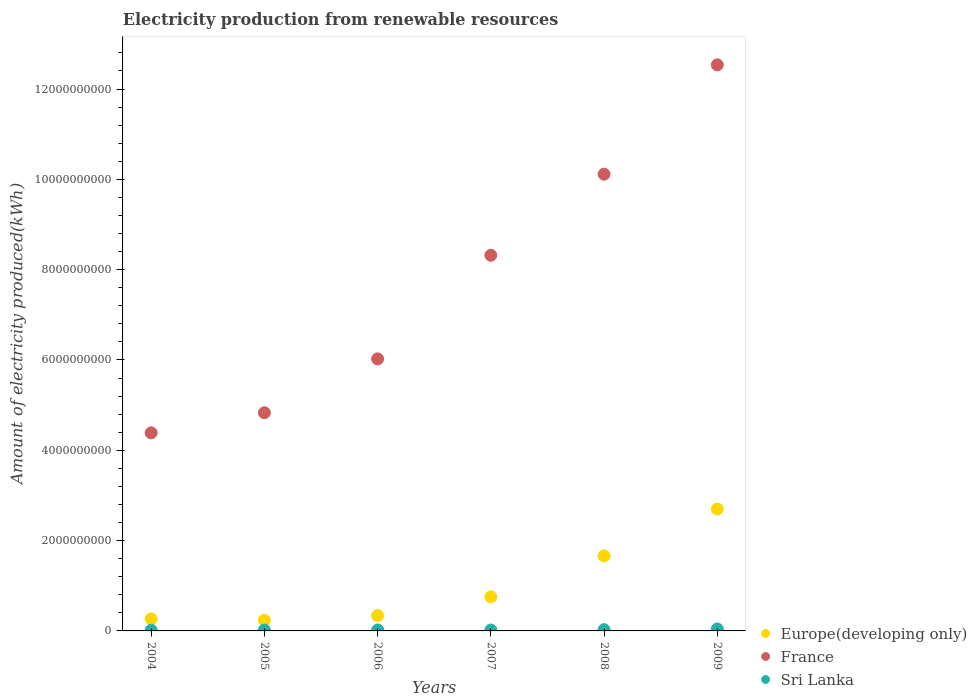How many different coloured dotlines are there?
Provide a short and direct response. 3. Is the number of dotlines equal to the number of legend labels?
Keep it short and to the point. Yes. Across all years, what is the maximum amount of electricity produced in France?
Provide a short and direct response. 1.25e+1. Across all years, what is the minimum amount of electricity produced in Europe(developing only)?
Keep it short and to the point. 2.37e+08. What is the total amount of electricity produced in Sri Lanka in the graph?
Your answer should be very brief. 1.46e+08. What is the difference between the amount of electricity produced in Europe(developing only) in 2007 and that in 2008?
Your answer should be compact. -9.09e+08. What is the difference between the amount of electricity produced in Europe(developing only) in 2004 and the amount of electricity produced in France in 2005?
Offer a very short reply. -4.56e+09. What is the average amount of electricity produced in Sri Lanka per year?
Ensure brevity in your answer.  2.43e+07. In the year 2007, what is the difference between the amount of electricity produced in France and amount of electricity produced in Europe(developing only)?
Offer a terse response. 7.56e+09. In how many years, is the amount of electricity produced in Sri Lanka greater than 2800000000 kWh?
Offer a very short reply. 0. What is the ratio of the amount of electricity produced in France in 2006 to that in 2008?
Ensure brevity in your answer.  0.6. Is the difference between the amount of electricity produced in France in 2008 and 2009 greater than the difference between the amount of electricity produced in Europe(developing only) in 2008 and 2009?
Give a very brief answer. No. What is the difference between the highest and the second highest amount of electricity produced in Sri Lanka?
Offer a very short reply. 1.60e+07. What is the difference between the highest and the lowest amount of electricity produced in Sri Lanka?
Give a very brief answer. 2.80e+07. Is the sum of the amount of electricity produced in Europe(developing only) in 2004 and 2006 greater than the maximum amount of electricity produced in France across all years?
Ensure brevity in your answer.  No. Does the amount of electricity produced in France monotonically increase over the years?
Your answer should be very brief. Yes. Is the amount of electricity produced in Sri Lanka strictly greater than the amount of electricity produced in France over the years?
Provide a short and direct response. No. How many years are there in the graph?
Offer a very short reply. 6. What is the difference between two consecutive major ticks on the Y-axis?
Give a very brief answer. 2.00e+09. Where does the legend appear in the graph?
Your answer should be very brief. Bottom right. How many legend labels are there?
Offer a terse response. 3. What is the title of the graph?
Provide a short and direct response. Electricity production from renewable resources. Does "Virgin Islands" appear as one of the legend labels in the graph?
Keep it short and to the point. No. What is the label or title of the X-axis?
Provide a short and direct response. Years. What is the label or title of the Y-axis?
Provide a short and direct response. Amount of electricity produced(kWh). What is the Amount of electricity produced(kWh) in Europe(developing only) in 2004?
Give a very brief answer. 2.66e+08. What is the Amount of electricity produced(kWh) of France in 2004?
Give a very brief answer. 4.39e+09. What is the Amount of electricity produced(kWh) of Sri Lanka in 2004?
Give a very brief answer. 1.50e+07. What is the Amount of electricity produced(kWh) in Europe(developing only) in 2005?
Your answer should be very brief. 2.37e+08. What is the Amount of electricity produced(kWh) of France in 2005?
Offer a terse response. 4.83e+09. What is the Amount of electricity produced(kWh) of Europe(developing only) in 2006?
Your response must be concise. 3.40e+08. What is the Amount of electricity produced(kWh) in France in 2006?
Provide a succinct answer. 6.02e+09. What is the Amount of electricity produced(kWh) in Sri Lanka in 2006?
Your answer should be compact. 2.10e+07. What is the Amount of electricity produced(kWh) in Europe(developing only) in 2007?
Give a very brief answer. 7.54e+08. What is the Amount of electricity produced(kWh) of France in 2007?
Give a very brief answer. 8.32e+09. What is the Amount of electricity produced(kWh) in Europe(developing only) in 2008?
Offer a very short reply. 1.66e+09. What is the Amount of electricity produced(kWh) in France in 2008?
Your answer should be very brief. 1.01e+1. What is the Amount of electricity produced(kWh) in Sri Lanka in 2008?
Ensure brevity in your answer.  2.70e+07. What is the Amount of electricity produced(kWh) of Europe(developing only) in 2009?
Make the answer very short. 2.70e+09. What is the Amount of electricity produced(kWh) in France in 2009?
Make the answer very short. 1.25e+1. What is the Amount of electricity produced(kWh) in Sri Lanka in 2009?
Make the answer very short. 4.30e+07. Across all years, what is the maximum Amount of electricity produced(kWh) in Europe(developing only)?
Ensure brevity in your answer.  2.70e+09. Across all years, what is the maximum Amount of electricity produced(kWh) in France?
Provide a succinct answer. 1.25e+1. Across all years, what is the maximum Amount of electricity produced(kWh) in Sri Lanka?
Make the answer very short. 4.30e+07. Across all years, what is the minimum Amount of electricity produced(kWh) in Europe(developing only)?
Give a very brief answer. 2.37e+08. Across all years, what is the minimum Amount of electricity produced(kWh) of France?
Your answer should be very brief. 4.39e+09. Across all years, what is the minimum Amount of electricity produced(kWh) of Sri Lanka?
Make the answer very short. 1.50e+07. What is the total Amount of electricity produced(kWh) in Europe(developing only) in the graph?
Ensure brevity in your answer.  5.96e+09. What is the total Amount of electricity produced(kWh) in France in the graph?
Your response must be concise. 4.62e+1. What is the total Amount of electricity produced(kWh) of Sri Lanka in the graph?
Provide a short and direct response. 1.46e+08. What is the difference between the Amount of electricity produced(kWh) of Europe(developing only) in 2004 and that in 2005?
Your response must be concise. 2.90e+07. What is the difference between the Amount of electricity produced(kWh) of France in 2004 and that in 2005?
Provide a short and direct response. -4.44e+08. What is the difference between the Amount of electricity produced(kWh) of Sri Lanka in 2004 and that in 2005?
Your answer should be compact. -5.00e+06. What is the difference between the Amount of electricity produced(kWh) of Europe(developing only) in 2004 and that in 2006?
Provide a succinct answer. -7.40e+07. What is the difference between the Amount of electricity produced(kWh) of France in 2004 and that in 2006?
Your response must be concise. -1.64e+09. What is the difference between the Amount of electricity produced(kWh) of Sri Lanka in 2004 and that in 2006?
Your answer should be compact. -6.00e+06. What is the difference between the Amount of electricity produced(kWh) in Europe(developing only) in 2004 and that in 2007?
Provide a short and direct response. -4.88e+08. What is the difference between the Amount of electricity produced(kWh) in France in 2004 and that in 2007?
Keep it short and to the point. -3.93e+09. What is the difference between the Amount of electricity produced(kWh) in Sri Lanka in 2004 and that in 2007?
Make the answer very short. -5.00e+06. What is the difference between the Amount of electricity produced(kWh) of Europe(developing only) in 2004 and that in 2008?
Offer a very short reply. -1.40e+09. What is the difference between the Amount of electricity produced(kWh) of France in 2004 and that in 2008?
Your answer should be compact. -5.73e+09. What is the difference between the Amount of electricity produced(kWh) of Sri Lanka in 2004 and that in 2008?
Give a very brief answer. -1.20e+07. What is the difference between the Amount of electricity produced(kWh) in Europe(developing only) in 2004 and that in 2009?
Your answer should be compact. -2.43e+09. What is the difference between the Amount of electricity produced(kWh) of France in 2004 and that in 2009?
Your answer should be compact. -8.15e+09. What is the difference between the Amount of electricity produced(kWh) of Sri Lanka in 2004 and that in 2009?
Your response must be concise. -2.80e+07. What is the difference between the Amount of electricity produced(kWh) in Europe(developing only) in 2005 and that in 2006?
Your answer should be very brief. -1.03e+08. What is the difference between the Amount of electricity produced(kWh) in France in 2005 and that in 2006?
Offer a very short reply. -1.19e+09. What is the difference between the Amount of electricity produced(kWh) in Europe(developing only) in 2005 and that in 2007?
Provide a short and direct response. -5.17e+08. What is the difference between the Amount of electricity produced(kWh) of France in 2005 and that in 2007?
Your response must be concise. -3.49e+09. What is the difference between the Amount of electricity produced(kWh) of Sri Lanka in 2005 and that in 2007?
Provide a succinct answer. 0. What is the difference between the Amount of electricity produced(kWh) of Europe(developing only) in 2005 and that in 2008?
Provide a succinct answer. -1.43e+09. What is the difference between the Amount of electricity produced(kWh) of France in 2005 and that in 2008?
Keep it short and to the point. -5.28e+09. What is the difference between the Amount of electricity produced(kWh) of Sri Lanka in 2005 and that in 2008?
Offer a very short reply. -7.00e+06. What is the difference between the Amount of electricity produced(kWh) of Europe(developing only) in 2005 and that in 2009?
Provide a short and direct response. -2.46e+09. What is the difference between the Amount of electricity produced(kWh) in France in 2005 and that in 2009?
Your answer should be compact. -7.70e+09. What is the difference between the Amount of electricity produced(kWh) of Sri Lanka in 2005 and that in 2009?
Offer a terse response. -2.30e+07. What is the difference between the Amount of electricity produced(kWh) of Europe(developing only) in 2006 and that in 2007?
Provide a succinct answer. -4.14e+08. What is the difference between the Amount of electricity produced(kWh) of France in 2006 and that in 2007?
Your answer should be compact. -2.30e+09. What is the difference between the Amount of electricity produced(kWh) in Sri Lanka in 2006 and that in 2007?
Your answer should be very brief. 1.00e+06. What is the difference between the Amount of electricity produced(kWh) in Europe(developing only) in 2006 and that in 2008?
Keep it short and to the point. -1.32e+09. What is the difference between the Amount of electricity produced(kWh) in France in 2006 and that in 2008?
Offer a terse response. -4.09e+09. What is the difference between the Amount of electricity produced(kWh) of Sri Lanka in 2006 and that in 2008?
Provide a short and direct response. -6.00e+06. What is the difference between the Amount of electricity produced(kWh) of Europe(developing only) in 2006 and that in 2009?
Your answer should be very brief. -2.36e+09. What is the difference between the Amount of electricity produced(kWh) in France in 2006 and that in 2009?
Give a very brief answer. -6.51e+09. What is the difference between the Amount of electricity produced(kWh) of Sri Lanka in 2006 and that in 2009?
Keep it short and to the point. -2.20e+07. What is the difference between the Amount of electricity produced(kWh) in Europe(developing only) in 2007 and that in 2008?
Provide a succinct answer. -9.09e+08. What is the difference between the Amount of electricity produced(kWh) in France in 2007 and that in 2008?
Your answer should be compact. -1.80e+09. What is the difference between the Amount of electricity produced(kWh) of Sri Lanka in 2007 and that in 2008?
Provide a succinct answer. -7.00e+06. What is the difference between the Amount of electricity produced(kWh) of Europe(developing only) in 2007 and that in 2009?
Offer a terse response. -1.94e+09. What is the difference between the Amount of electricity produced(kWh) in France in 2007 and that in 2009?
Give a very brief answer. -4.22e+09. What is the difference between the Amount of electricity produced(kWh) of Sri Lanka in 2007 and that in 2009?
Your response must be concise. -2.30e+07. What is the difference between the Amount of electricity produced(kWh) of Europe(developing only) in 2008 and that in 2009?
Your answer should be compact. -1.04e+09. What is the difference between the Amount of electricity produced(kWh) of France in 2008 and that in 2009?
Offer a terse response. -2.42e+09. What is the difference between the Amount of electricity produced(kWh) of Sri Lanka in 2008 and that in 2009?
Your answer should be compact. -1.60e+07. What is the difference between the Amount of electricity produced(kWh) of Europe(developing only) in 2004 and the Amount of electricity produced(kWh) of France in 2005?
Make the answer very short. -4.56e+09. What is the difference between the Amount of electricity produced(kWh) of Europe(developing only) in 2004 and the Amount of electricity produced(kWh) of Sri Lanka in 2005?
Your response must be concise. 2.46e+08. What is the difference between the Amount of electricity produced(kWh) in France in 2004 and the Amount of electricity produced(kWh) in Sri Lanka in 2005?
Offer a terse response. 4.37e+09. What is the difference between the Amount of electricity produced(kWh) in Europe(developing only) in 2004 and the Amount of electricity produced(kWh) in France in 2006?
Give a very brief answer. -5.76e+09. What is the difference between the Amount of electricity produced(kWh) of Europe(developing only) in 2004 and the Amount of electricity produced(kWh) of Sri Lanka in 2006?
Provide a short and direct response. 2.45e+08. What is the difference between the Amount of electricity produced(kWh) in France in 2004 and the Amount of electricity produced(kWh) in Sri Lanka in 2006?
Provide a short and direct response. 4.37e+09. What is the difference between the Amount of electricity produced(kWh) in Europe(developing only) in 2004 and the Amount of electricity produced(kWh) in France in 2007?
Your answer should be compact. -8.05e+09. What is the difference between the Amount of electricity produced(kWh) in Europe(developing only) in 2004 and the Amount of electricity produced(kWh) in Sri Lanka in 2007?
Give a very brief answer. 2.46e+08. What is the difference between the Amount of electricity produced(kWh) of France in 2004 and the Amount of electricity produced(kWh) of Sri Lanka in 2007?
Your response must be concise. 4.37e+09. What is the difference between the Amount of electricity produced(kWh) in Europe(developing only) in 2004 and the Amount of electricity produced(kWh) in France in 2008?
Provide a short and direct response. -9.85e+09. What is the difference between the Amount of electricity produced(kWh) of Europe(developing only) in 2004 and the Amount of electricity produced(kWh) of Sri Lanka in 2008?
Provide a short and direct response. 2.39e+08. What is the difference between the Amount of electricity produced(kWh) in France in 2004 and the Amount of electricity produced(kWh) in Sri Lanka in 2008?
Your answer should be compact. 4.36e+09. What is the difference between the Amount of electricity produced(kWh) in Europe(developing only) in 2004 and the Amount of electricity produced(kWh) in France in 2009?
Offer a terse response. -1.23e+1. What is the difference between the Amount of electricity produced(kWh) of Europe(developing only) in 2004 and the Amount of electricity produced(kWh) of Sri Lanka in 2009?
Offer a terse response. 2.23e+08. What is the difference between the Amount of electricity produced(kWh) of France in 2004 and the Amount of electricity produced(kWh) of Sri Lanka in 2009?
Keep it short and to the point. 4.34e+09. What is the difference between the Amount of electricity produced(kWh) of Europe(developing only) in 2005 and the Amount of electricity produced(kWh) of France in 2006?
Your answer should be very brief. -5.79e+09. What is the difference between the Amount of electricity produced(kWh) of Europe(developing only) in 2005 and the Amount of electricity produced(kWh) of Sri Lanka in 2006?
Make the answer very short. 2.16e+08. What is the difference between the Amount of electricity produced(kWh) in France in 2005 and the Amount of electricity produced(kWh) in Sri Lanka in 2006?
Offer a terse response. 4.81e+09. What is the difference between the Amount of electricity produced(kWh) in Europe(developing only) in 2005 and the Amount of electricity produced(kWh) in France in 2007?
Provide a succinct answer. -8.08e+09. What is the difference between the Amount of electricity produced(kWh) in Europe(developing only) in 2005 and the Amount of electricity produced(kWh) in Sri Lanka in 2007?
Offer a terse response. 2.17e+08. What is the difference between the Amount of electricity produced(kWh) of France in 2005 and the Amount of electricity produced(kWh) of Sri Lanka in 2007?
Ensure brevity in your answer.  4.81e+09. What is the difference between the Amount of electricity produced(kWh) in Europe(developing only) in 2005 and the Amount of electricity produced(kWh) in France in 2008?
Offer a very short reply. -9.88e+09. What is the difference between the Amount of electricity produced(kWh) of Europe(developing only) in 2005 and the Amount of electricity produced(kWh) of Sri Lanka in 2008?
Your answer should be very brief. 2.10e+08. What is the difference between the Amount of electricity produced(kWh) in France in 2005 and the Amount of electricity produced(kWh) in Sri Lanka in 2008?
Ensure brevity in your answer.  4.80e+09. What is the difference between the Amount of electricity produced(kWh) of Europe(developing only) in 2005 and the Amount of electricity produced(kWh) of France in 2009?
Your response must be concise. -1.23e+1. What is the difference between the Amount of electricity produced(kWh) in Europe(developing only) in 2005 and the Amount of electricity produced(kWh) in Sri Lanka in 2009?
Your answer should be compact. 1.94e+08. What is the difference between the Amount of electricity produced(kWh) in France in 2005 and the Amount of electricity produced(kWh) in Sri Lanka in 2009?
Offer a terse response. 4.79e+09. What is the difference between the Amount of electricity produced(kWh) of Europe(developing only) in 2006 and the Amount of electricity produced(kWh) of France in 2007?
Your answer should be compact. -7.98e+09. What is the difference between the Amount of electricity produced(kWh) of Europe(developing only) in 2006 and the Amount of electricity produced(kWh) of Sri Lanka in 2007?
Keep it short and to the point. 3.20e+08. What is the difference between the Amount of electricity produced(kWh) in France in 2006 and the Amount of electricity produced(kWh) in Sri Lanka in 2007?
Ensure brevity in your answer.  6.00e+09. What is the difference between the Amount of electricity produced(kWh) in Europe(developing only) in 2006 and the Amount of electricity produced(kWh) in France in 2008?
Make the answer very short. -9.77e+09. What is the difference between the Amount of electricity produced(kWh) in Europe(developing only) in 2006 and the Amount of electricity produced(kWh) in Sri Lanka in 2008?
Give a very brief answer. 3.13e+08. What is the difference between the Amount of electricity produced(kWh) of France in 2006 and the Amount of electricity produced(kWh) of Sri Lanka in 2008?
Your answer should be compact. 6.00e+09. What is the difference between the Amount of electricity produced(kWh) in Europe(developing only) in 2006 and the Amount of electricity produced(kWh) in France in 2009?
Give a very brief answer. -1.22e+1. What is the difference between the Amount of electricity produced(kWh) in Europe(developing only) in 2006 and the Amount of electricity produced(kWh) in Sri Lanka in 2009?
Provide a succinct answer. 2.97e+08. What is the difference between the Amount of electricity produced(kWh) in France in 2006 and the Amount of electricity produced(kWh) in Sri Lanka in 2009?
Make the answer very short. 5.98e+09. What is the difference between the Amount of electricity produced(kWh) in Europe(developing only) in 2007 and the Amount of electricity produced(kWh) in France in 2008?
Keep it short and to the point. -9.36e+09. What is the difference between the Amount of electricity produced(kWh) in Europe(developing only) in 2007 and the Amount of electricity produced(kWh) in Sri Lanka in 2008?
Provide a succinct answer. 7.27e+08. What is the difference between the Amount of electricity produced(kWh) of France in 2007 and the Amount of electricity produced(kWh) of Sri Lanka in 2008?
Ensure brevity in your answer.  8.29e+09. What is the difference between the Amount of electricity produced(kWh) in Europe(developing only) in 2007 and the Amount of electricity produced(kWh) in France in 2009?
Offer a terse response. -1.18e+1. What is the difference between the Amount of electricity produced(kWh) of Europe(developing only) in 2007 and the Amount of electricity produced(kWh) of Sri Lanka in 2009?
Ensure brevity in your answer.  7.11e+08. What is the difference between the Amount of electricity produced(kWh) in France in 2007 and the Amount of electricity produced(kWh) in Sri Lanka in 2009?
Provide a succinct answer. 8.28e+09. What is the difference between the Amount of electricity produced(kWh) of Europe(developing only) in 2008 and the Amount of electricity produced(kWh) of France in 2009?
Your answer should be compact. -1.09e+1. What is the difference between the Amount of electricity produced(kWh) of Europe(developing only) in 2008 and the Amount of electricity produced(kWh) of Sri Lanka in 2009?
Keep it short and to the point. 1.62e+09. What is the difference between the Amount of electricity produced(kWh) in France in 2008 and the Amount of electricity produced(kWh) in Sri Lanka in 2009?
Offer a terse response. 1.01e+1. What is the average Amount of electricity produced(kWh) in Europe(developing only) per year?
Keep it short and to the point. 9.93e+08. What is the average Amount of electricity produced(kWh) in France per year?
Provide a succinct answer. 7.70e+09. What is the average Amount of electricity produced(kWh) of Sri Lanka per year?
Provide a short and direct response. 2.43e+07. In the year 2004, what is the difference between the Amount of electricity produced(kWh) in Europe(developing only) and Amount of electricity produced(kWh) in France?
Keep it short and to the point. -4.12e+09. In the year 2004, what is the difference between the Amount of electricity produced(kWh) in Europe(developing only) and Amount of electricity produced(kWh) in Sri Lanka?
Your answer should be compact. 2.51e+08. In the year 2004, what is the difference between the Amount of electricity produced(kWh) of France and Amount of electricity produced(kWh) of Sri Lanka?
Your response must be concise. 4.37e+09. In the year 2005, what is the difference between the Amount of electricity produced(kWh) of Europe(developing only) and Amount of electricity produced(kWh) of France?
Offer a very short reply. -4.59e+09. In the year 2005, what is the difference between the Amount of electricity produced(kWh) of Europe(developing only) and Amount of electricity produced(kWh) of Sri Lanka?
Your answer should be very brief. 2.17e+08. In the year 2005, what is the difference between the Amount of electricity produced(kWh) in France and Amount of electricity produced(kWh) in Sri Lanka?
Offer a very short reply. 4.81e+09. In the year 2006, what is the difference between the Amount of electricity produced(kWh) of Europe(developing only) and Amount of electricity produced(kWh) of France?
Offer a very short reply. -5.68e+09. In the year 2006, what is the difference between the Amount of electricity produced(kWh) of Europe(developing only) and Amount of electricity produced(kWh) of Sri Lanka?
Ensure brevity in your answer.  3.19e+08. In the year 2006, what is the difference between the Amount of electricity produced(kWh) in France and Amount of electricity produced(kWh) in Sri Lanka?
Keep it short and to the point. 6.00e+09. In the year 2007, what is the difference between the Amount of electricity produced(kWh) of Europe(developing only) and Amount of electricity produced(kWh) of France?
Give a very brief answer. -7.56e+09. In the year 2007, what is the difference between the Amount of electricity produced(kWh) of Europe(developing only) and Amount of electricity produced(kWh) of Sri Lanka?
Keep it short and to the point. 7.34e+08. In the year 2007, what is the difference between the Amount of electricity produced(kWh) in France and Amount of electricity produced(kWh) in Sri Lanka?
Provide a short and direct response. 8.30e+09. In the year 2008, what is the difference between the Amount of electricity produced(kWh) of Europe(developing only) and Amount of electricity produced(kWh) of France?
Give a very brief answer. -8.45e+09. In the year 2008, what is the difference between the Amount of electricity produced(kWh) in Europe(developing only) and Amount of electricity produced(kWh) in Sri Lanka?
Your answer should be compact. 1.64e+09. In the year 2008, what is the difference between the Amount of electricity produced(kWh) in France and Amount of electricity produced(kWh) in Sri Lanka?
Your answer should be compact. 1.01e+1. In the year 2009, what is the difference between the Amount of electricity produced(kWh) in Europe(developing only) and Amount of electricity produced(kWh) in France?
Your answer should be very brief. -9.84e+09. In the year 2009, what is the difference between the Amount of electricity produced(kWh) of Europe(developing only) and Amount of electricity produced(kWh) of Sri Lanka?
Ensure brevity in your answer.  2.66e+09. In the year 2009, what is the difference between the Amount of electricity produced(kWh) in France and Amount of electricity produced(kWh) in Sri Lanka?
Keep it short and to the point. 1.25e+1. What is the ratio of the Amount of electricity produced(kWh) of Europe(developing only) in 2004 to that in 2005?
Give a very brief answer. 1.12. What is the ratio of the Amount of electricity produced(kWh) of France in 2004 to that in 2005?
Give a very brief answer. 0.91. What is the ratio of the Amount of electricity produced(kWh) in Europe(developing only) in 2004 to that in 2006?
Provide a succinct answer. 0.78. What is the ratio of the Amount of electricity produced(kWh) in France in 2004 to that in 2006?
Provide a succinct answer. 0.73. What is the ratio of the Amount of electricity produced(kWh) in Sri Lanka in 2004 to that in 2006?
Your response must be concise. 0.71. What is the ratio of the Amount of electricity produced(kWh) in Europe(developing only) in 2004 to that in 2007?
Make the answer very short. 0.35. What is the ratio of the Amount of electricity produced(kWh) of France in 2004 to that in 2007?
Offer a terse response. 0.53. What is the ratio of the Amount of electricity produced(kWh) of Sri Lanka in 2004 to that in 2007?
Keep it short and to the point. 0.75. What is the ratio of the Amount of electricity produced(kWh) in Europe(developing only) in 2004 to that in 2008?
Make the answer very short. 0.16. What is the ratio of the Amount of electricity produced(kWh) of France in 2004 to that in 2008?
Your response must be concise. 0.43. What is the ratio of the Amount of electricity produced(kWh) in Sri Lanka in 2004 to that in 2008?
Provide a short and direct response. 0.56. What is the ratio of the Amount of electricity produced(kWh) of Europe(developing only) in 2004 to that in 2009?
Offer a terse response. 0.1. What is the ratio of the Amount of electricity produced(kWh) of France in 2004 to that in 2009?
Your answer should be compact. 0.35. What is the ratio of the Amount of electricity produced(kWh) in Sri Lanka in 2004 to that in 2009?
Your response must be concise. 0.35. What is the ratio of the Amount of electricity produced(kWh) in Europe(developing only) in 2005 to that in 2006?
Ensure brevity in your answer.  0.7. What is the ratio of the Amount of electricity produced(kWh) in France in 2005 to that in 2006?
Offer a very short reply. 0.8. What is the ratio of the Amount of electricity produced(kWh) of Sri Lanka in 2005 to that in 2006?
Provide a short and direct response. 0.95. What is the ratio of the Amount of electricity produced(kWh) of Europe(developing only) in 2005 to that in 2007?
Your response must be concise. 0.31. What is the ratio of the Amount of electricity produced(kWh) in France in 2005 to that in 2007?
Provide a succinct answer. 0.58. What is the ratio of the Amount of electricity produced(kWh) of Sri Lanka in 2005 to that in 2007?
Keep it short and to the point. 1. What is the ratio of the Amount of electricity produced(kWh) of Europe(developing only) in 2005 to that in 2008?
Provide a short and direct response. 0.14. What is the ratio of the Amount of electricity produced(kWh) in France in 2005 to that in 2008?
Provide a succinct answer. 0.48. What is the ratio of the Amount of electricity produced(kWh) of Sri Lanka in 2005 to that in 2008?
Give a very brief answer. 0.74. What is the ratio of the Amount of electricity produced(kWh) of Europe(developing only) in 2005 to that in 2009?
Offer a terse response. 0.09. What is the ratio of the Amount of electricity produced(kWh) of France in 2005 to that in 2009?
Make the answer very short. 0.39. What is the ratio of the Amount of electricity produced(kWh) of Sri Lanka in 2005 to that in 2009?
Ensure brevity in your answer.  0.47. What is the ratio of the Amount of electricity produced(kWh) of Europe(developing only) in 2006 to that in 2007?
Provide a short and direct response. 0.45. What is the ratio of the Amount of electricity produced(kWh) in France in 2006 to that in 2007?
Your answer should be compact. 0.72. What is the ratio of the Amount of electricity produced(kWh) in Sri Lanka in 2006 to that in 2007?
Your answer should be very brief. 1.05. What is the ratio of the Amount of electricity produced(kWh) in Europe(developing only) in 2006 to that in 2008?
Keep it short and to the point. 0.2. What is the ratio of the Amount of electricity produced(kWh) in France in 2006 to that in 2008?
Your answer should be very brief. 0.6. What is the ratio of the Amount of electricity produced(kWh) of Sri Lanka in 2006 to that in 2008?
Your response must be concise. 0.78. What is the ratio of the Amount of electricity produced(kWh) in Europe(developing only) in 2006 to that in 2009?
Offer a very short reply. 0.13. What is the ratio of the Amount of electricity produced(kWh) of France in 2006 to that in 2009?
Make the answer very short. 0.48. What is the ratio of the Amount of electricity produced(kWh) of Sri Lanka in 2006 to that in 2009?
Provide a succinct answer. 0.49. What is the ratio of the Amount of electricity produced(kWh) of Europe(developing only) in 2007 to that in 2008?
Keep it short and to the point. 0.45. What is the ratio of the Amount of electricity produced(kWh) in France in 2007 to that in 2008?
Provide a succinct answer. 0.82. What is the ratio of the Amount of electricity produced(kWh) in Sri Lanka in 2007 to that in 2008?
Your answer should be compact. 0.74. What is the ratio of the Amount of electricity produced(kWh) of Europe(developing only) in 2007 to that in 2009?
Keep it short and to the point. 0.28. What is the ratio of the Amount of electricity produced(kWh) of France in 2007 to that in 2009?
Your answer should be compact. 0.66. What is the ratio of the Amount of electricity produced(kWh) in Sri Lanka in 2007 to that in 2009?
Your answer should be compact. 0.47. What is the ratio of the Amount of electricity produced(kWh) in Europe(developing only) in 2008 to that in 2009?
Offer a terse response. 0.62. What is the ratio of the Amount of electricity produced(kWh) in France in 2008 to that in 2009?
Give a very brief answer. 0.81. What is the ratio of the Amount of electricity produced(kWh) in Sri Lanka in 2008 to that in 2009?
Offer a very short reply. 0.63. What is the difference between the highest and the second highest Amount of electricity produced(kWh) of Europe(developing only)?
Offer a very short reply. 1.04e+09. What is the difference between the highest and the second highest Amount of electricity produced(kWh) of France?
Provide a succinct answer. 2.42e+09. What is the difference between the highest and the second highest Amount of electricity produced(kWh) in Sri Lanka?
Make the answer very short. 1.60e+07. What is the difference between the highest and the lowest Amount of electricity produced(kWh) of Europe(developing only)?
Ensure brevity in your answer.  2.46e+09. What is the difference between the highest and the lowest Amount of electricity produced(kWh) of France?
Your response must be concise. 8.15e+09. What is the difference between the highest and the lowest Amount of electricity produced(kWh) in Sri Lanka?
Your response must be concise. 2.80e+07. 